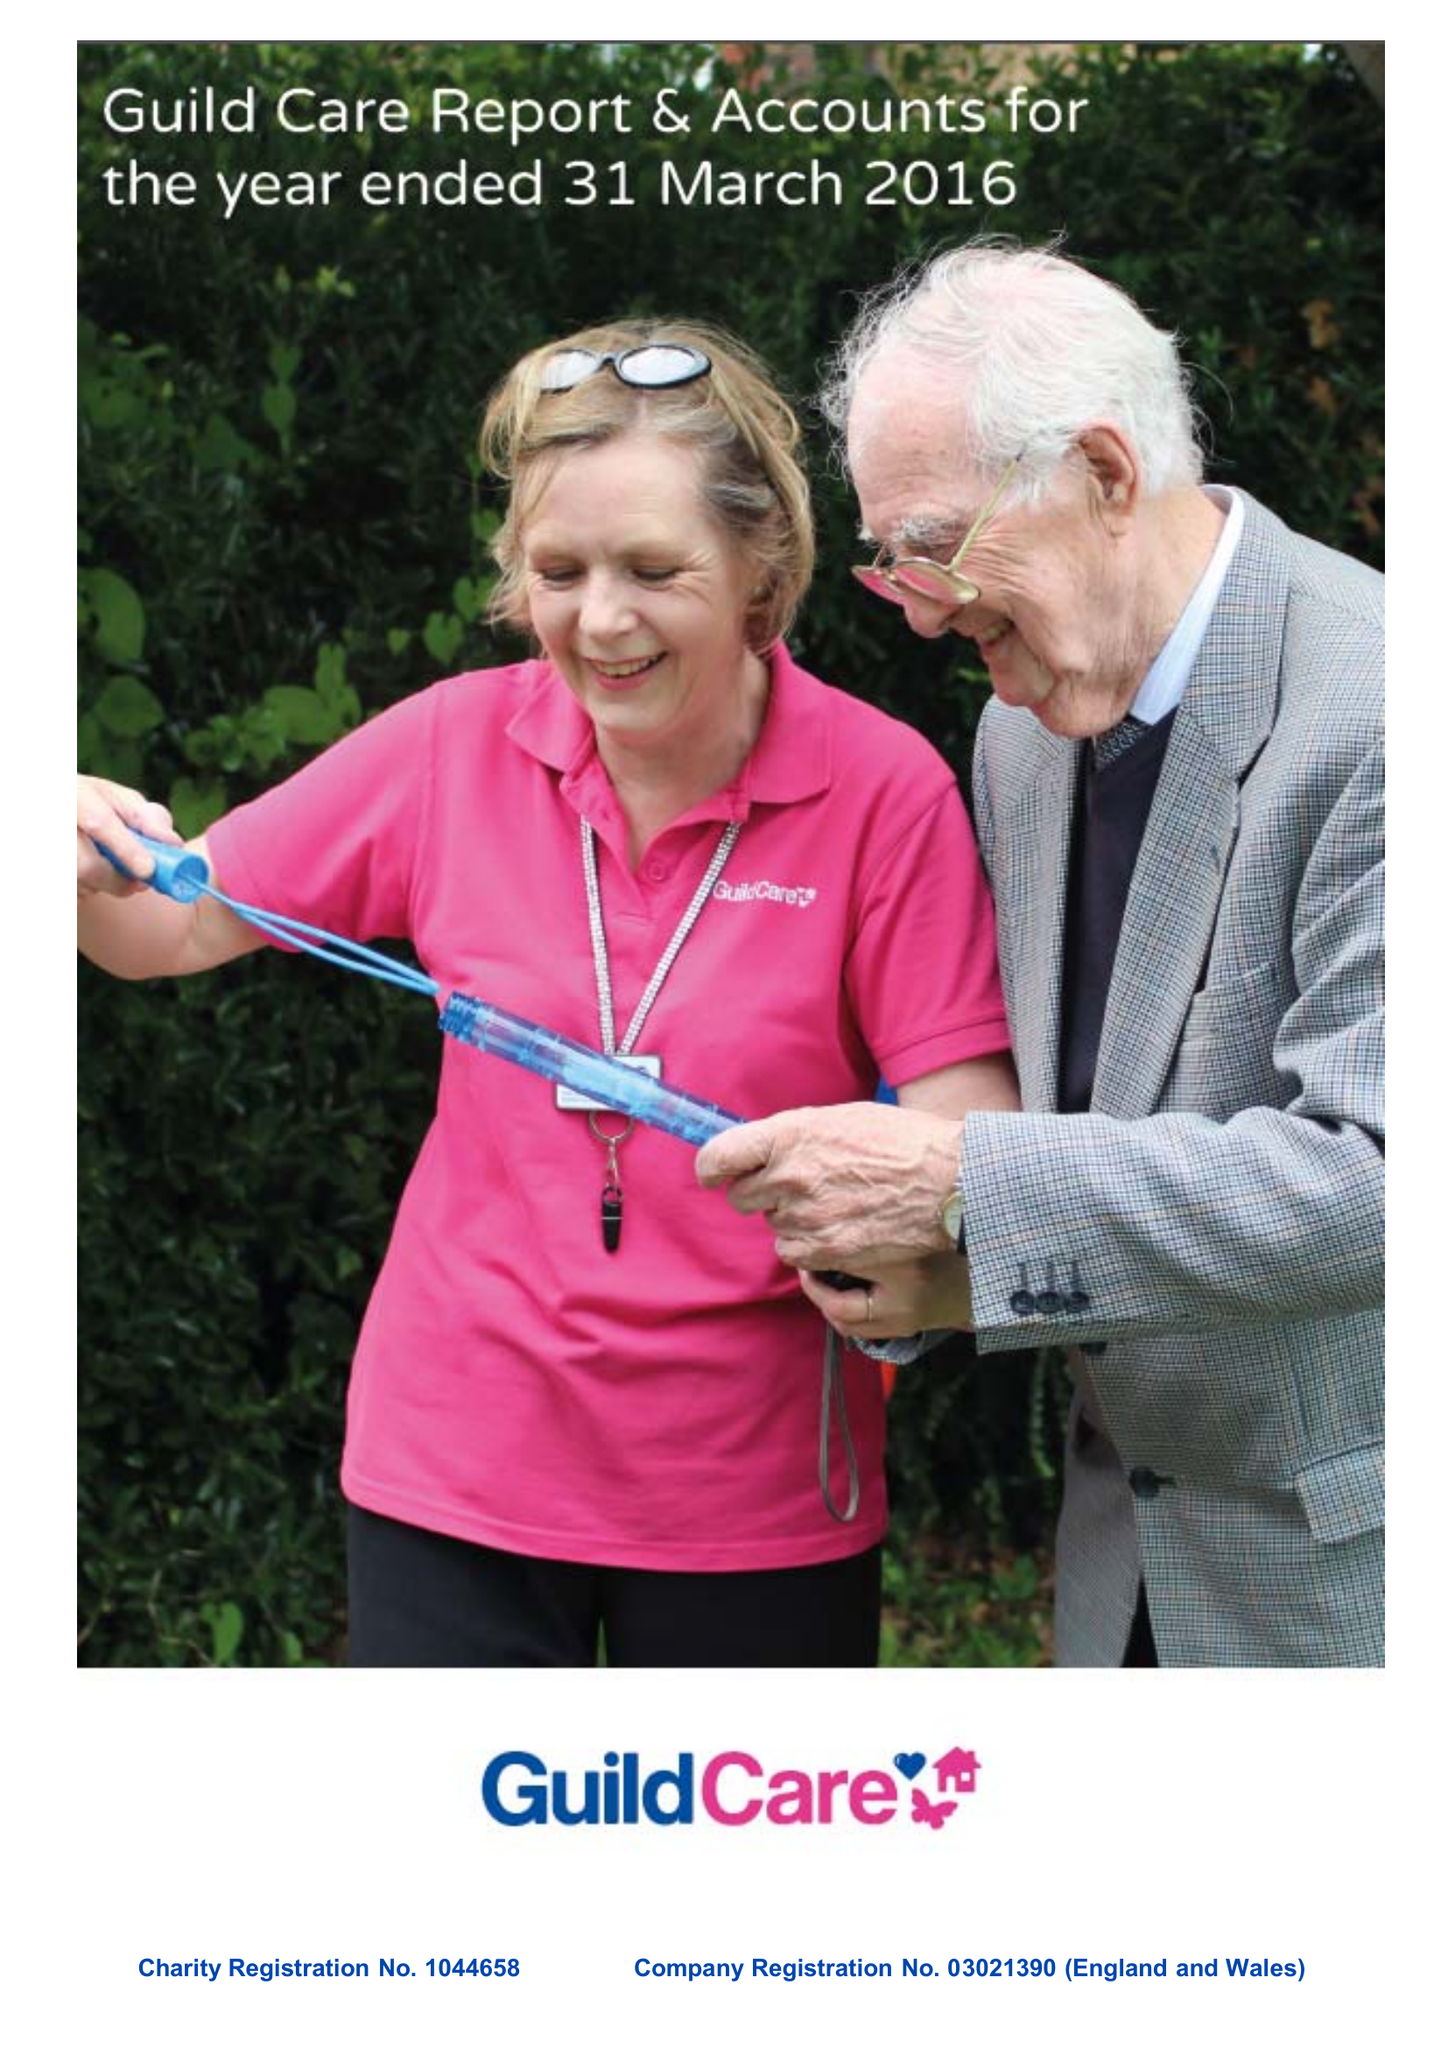What is the value for the report_date?
Answer the question using a single word or phrase. 2016-03-31 